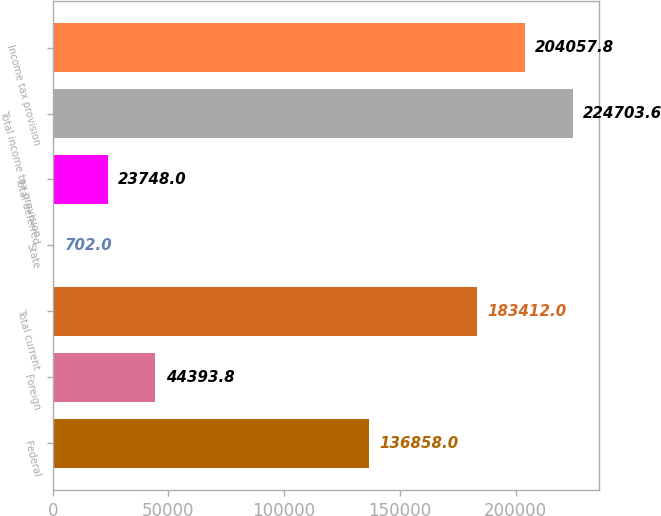Convert chart to OTSL. <chart><loc_0><loc_0><loc_500><loc_500><bar_chart><fcel>Federal<fcel>Foreign<fcel>Total current<fcel>State<fcel>Total deferred<fcel>Total income tax provision<fcel>Income tax provision<nl><fcel>136858<fcel>44393.8<fcel>183412<fcel>702<fcel>23748<fcel>224704<fcel>204058<nl></chart> 